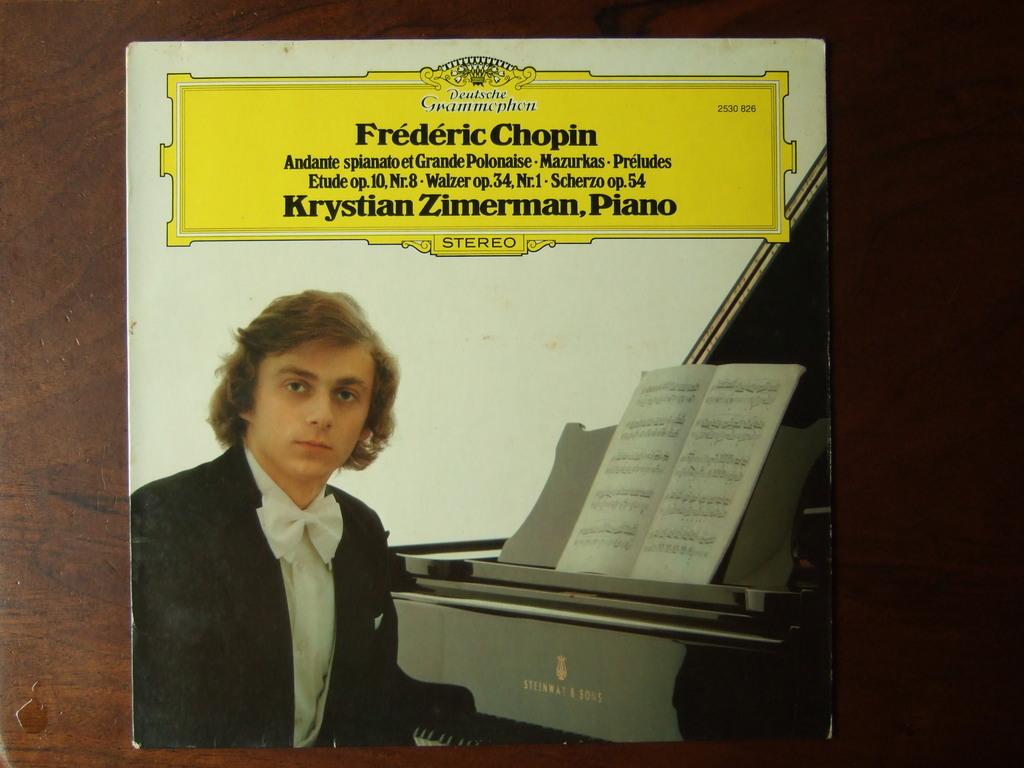What album is this?
Your response must be concise. Frederic chopin. Who is on the page?
Provide a short and direct response. Frederic chopin. 